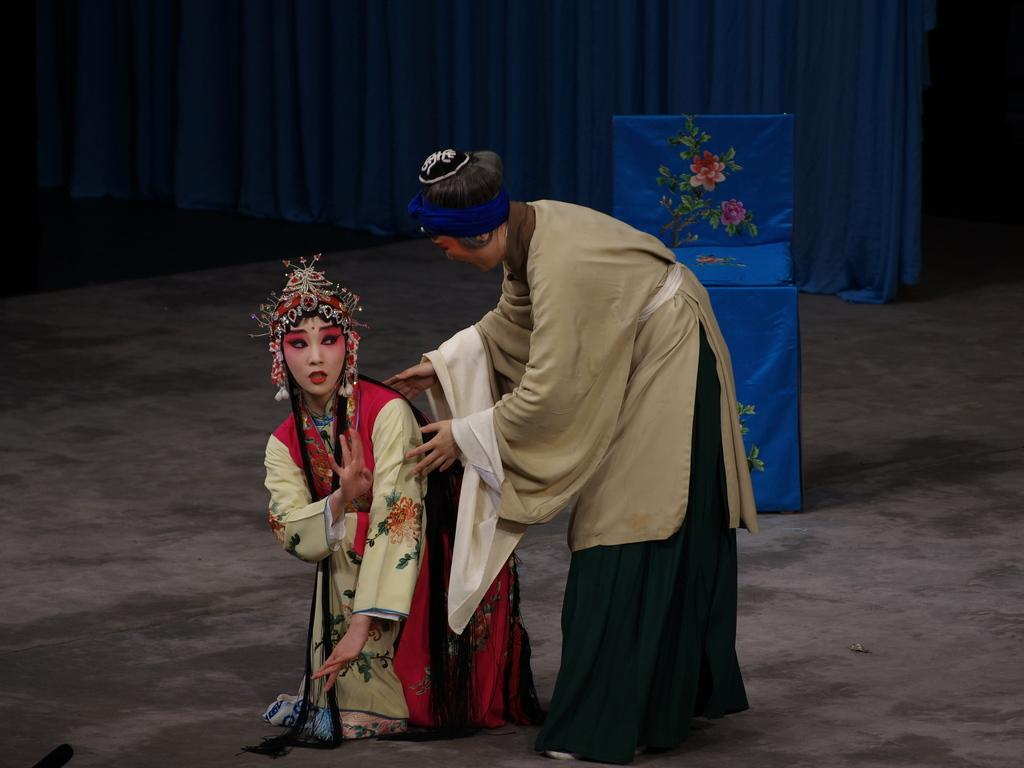How many people are on the stage in the foreground? There are two persons on the stage in the foreground. What is located on the stage with the people? There is a table in the foreground. What can be seen in the background of the image? There are curtains in the background. What type of setting is suggested by the presence of a stage? The image is likely taken on a stage, which suggests a performance or presentation. Are there any houses visible in the image? No, there are no houses visible in the image. Is there a party happening on the stage in the image? There is no indication of a party in the image; it simply shows two people and a table on a stage. 